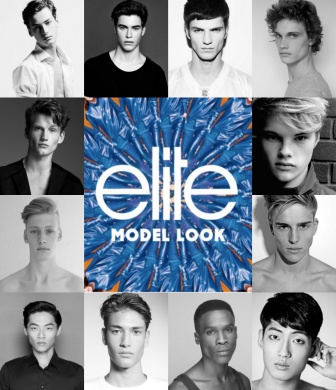Describe the following image. The image is a visually striking collage featuring 12 monochromatic headshots of young male models, each looking directly at the camera. The models display a variety of hairstyles and simple white t-shirts, adding a sense of unity and focus on their facial features. These headshots are meticulously arranged in a grid pattern, encircling a central, vibrant logo.

At the heart of the collage lies the colorful Elite Model Look logo, which features a dynamic blue and orange tropical leaf pattern. The words 'elite' and 'model look' are prominently displayed in white, providing a stark contrast to the colorful background. This central logo draws the viewer's focus, emphasizing the branding of the Elite Model Look competition.

The overall composition is symmetrical and balanced, with the monochromatic headshots providing a striking contrast to the colorful logo. The strategic placement of the headshots around the logo creates a radiating effect, effectively highlighting the central branding element. The collage appears to be promotional material for the Elite Model Look competition, celebrating the individuality and diversity of its participants while maintaining a cohesive and visually appealing design. 